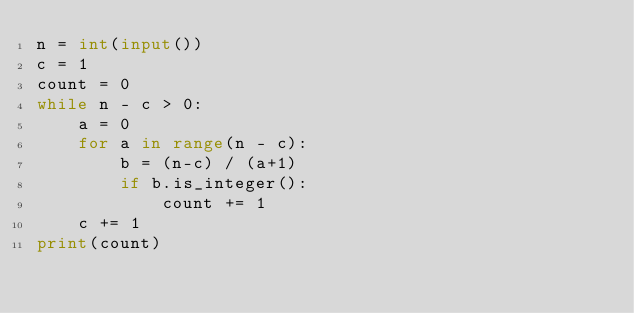Convert code to text. <code><loc_0><loc_0><loc_500><loc_500><_Python_>n = int(input())
c = 1
count = 0
while n - c > 0:
    a = 0
    for a in range(n - c):
        b = (n-c) / (a+1)
        if b.is_integer():
            count += 1
    c += 1
print(count)
</code> 